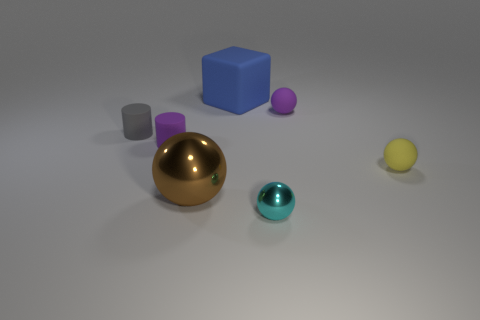Subtract all yellow cylinders. Subtract all red balls. How many cylinders are left? 2 Subtract all purple spheres. How many purple blocks are left? 0 Add 3 yellows. How many browns exist? 0 Subtract all green shiny objects. Subtract all tiny purple objects. How many objects are left? 5 Add 6 gray things. How many gray things are left? 7 Add 6 green matte cylinders. How many green matte cylinders exist? 6 Add 2 cyan metallic objects. How many objects exist? 9 Subtract all purple cylinders. How many cylinders are left? 1 Subtract all brown balls. How many balls are left? 3 Subtract 1 brown spheres. How many objects are left? 6 